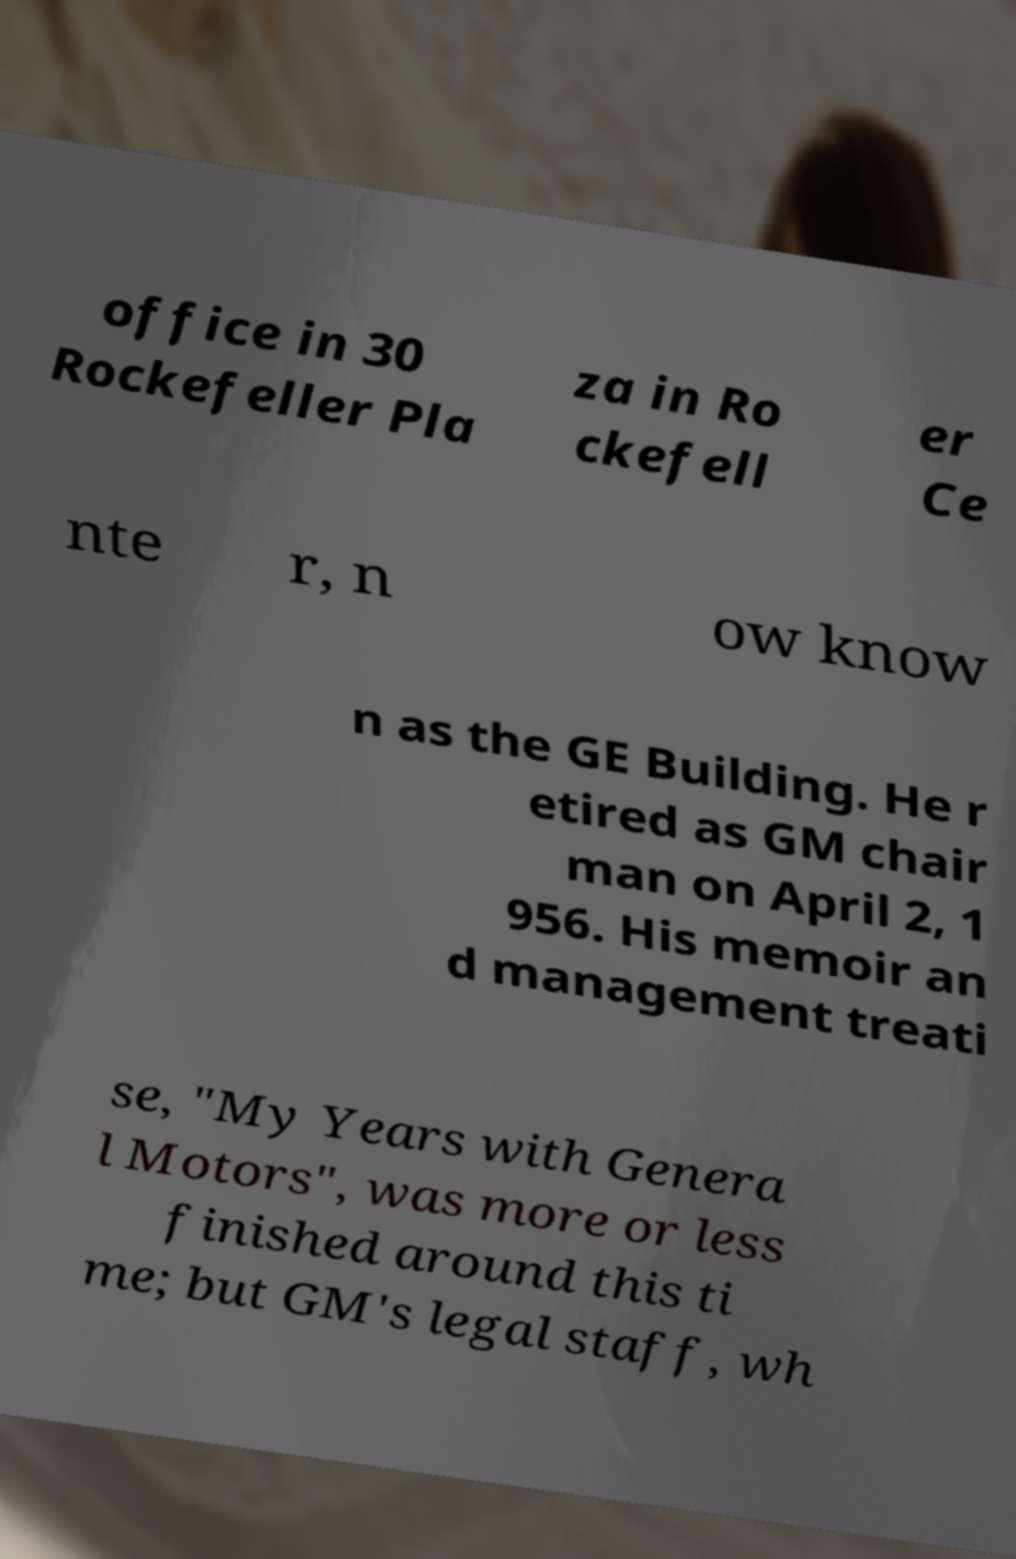For documentation purposes, I need the text within this image transcribed. Could you provide that? office in 30 Rockefeller Pla za in Ro ckefell er Ce nte r, n ow know n as the GE Building. He r etired as GM chair man on April 2, 1 956. His memoir an d management treati se, "My Years with Genera l Motors", was more or less finished around this ti me; but GM's legal staff, wh 